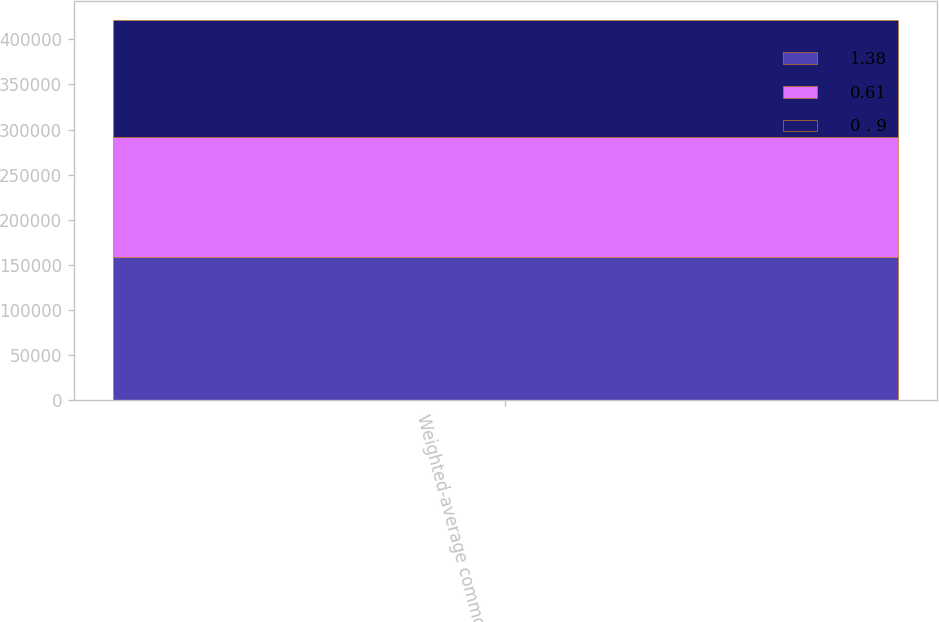Convert chart. <chart><loc_0><loc_0><loc_500><loc_500><stacked_bar_chart><ecel><fcel>Weighted-average common shares<nl><fcel>1.38<fcel>158326<nl><fcel>0.61<fcel>133616<nl><fcel>0 . 9<fcel>129318<nl></chart> 